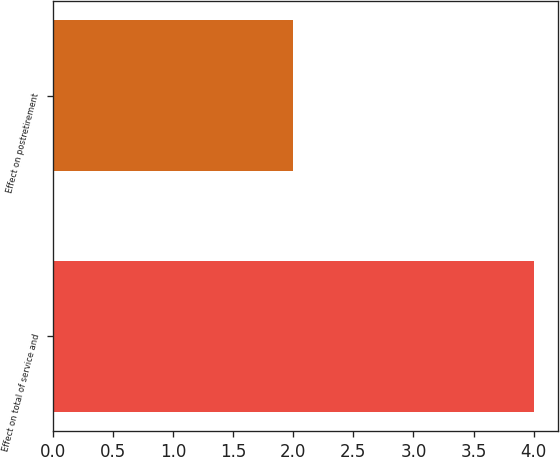Convert chart. <chart><loc_0><loc_0><loc_500><loc_500><bar_chart><fcel>Effect on total of service and<fcel>Effect on postretirement<nl><fcel>4<fcel>2<nl></chart> 